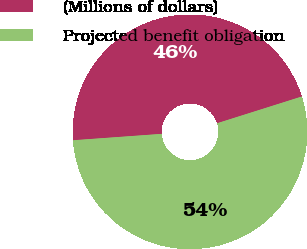Convert chart to OTSL. <chart><loc_0><loc_0><loc_500><loc_500><pie_chart><fcel>(Millions of dollars)<fcel>Projected benefit obligation<nl><fcel>46.28%<fcel>53.72%<nl></chart> 